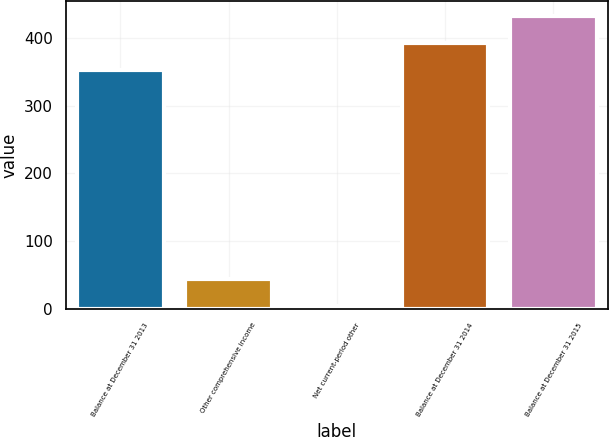Convert chart. <chart><loc_0><loc_0><loc_500><loc_500><bar_chart><fcel>Balance at December 31 2013<fcel>Other comprehensive income<fcel>Net current-period other<fcel>Balance at December 31 2014<fcel>Balance at December 31 2015<nl><fcel>352<fcel>44.1<fcel>4<fcel>392.1<fcel>432.2<nl></chart> 